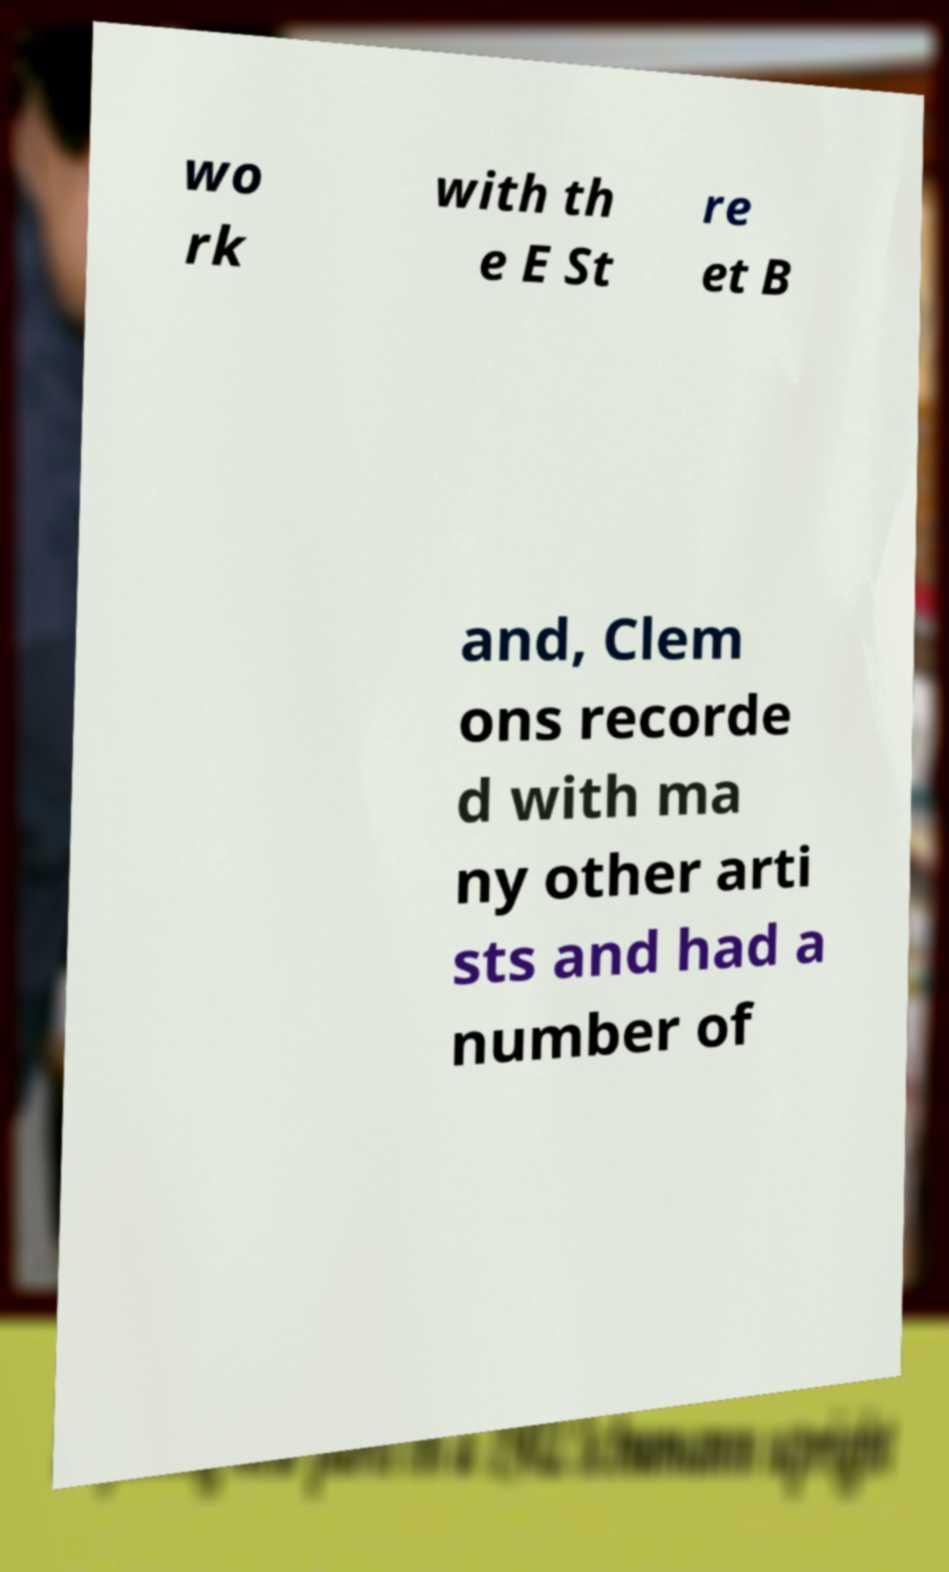Can you read and provide the text displayed in the image?This photo seems to have some interesting text. Can you extract and type it out for me? wo rk with th e E St re et B and, Clem ons recorde d with ma ny other arti sts and had a number of 